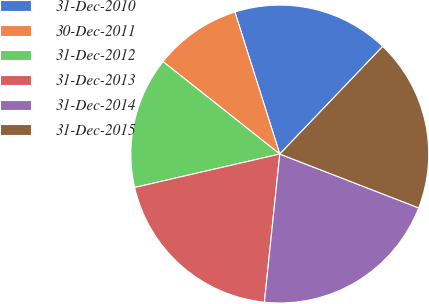Convert chart to OTSL. <chart><loc_0><loc_0><loc_500><loc_500><pie_chart><fcel>31-Dec-2010<fcel>30-Dec-2011<fcel>31-Dec-2012<fcel>31-Dec-2013<fcel>31-Dec-2014<fcel>31-Dec-2015<nl><fcel>17.02%<fcel>9.47%<fcel>14.26%<fcel>19.75%<fcel>20.76%<fcel>18.74%<nl></chart> 